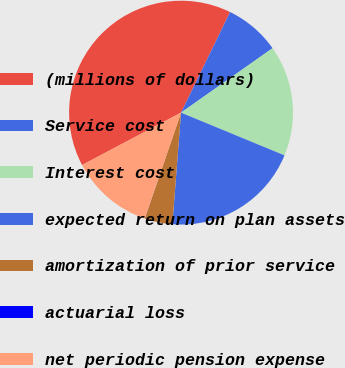<chart> <loc_0><loc_0><loc_500><loc_500><pie_chart><fcel>(millions of dollars)<fcel>Service cost<fcel>Interest cost<fcel>expected return on plan assets<fcel>amortization of prior service<fcel>actuarial loss<fcel>net periodic pension expense<nl><fcel>39.98%<fcel>8.01%<fcel>16.0%<fcel>20.0%<fcel>4.01%<fcel>0.01%<fcel>12.0%<nl></chart> 